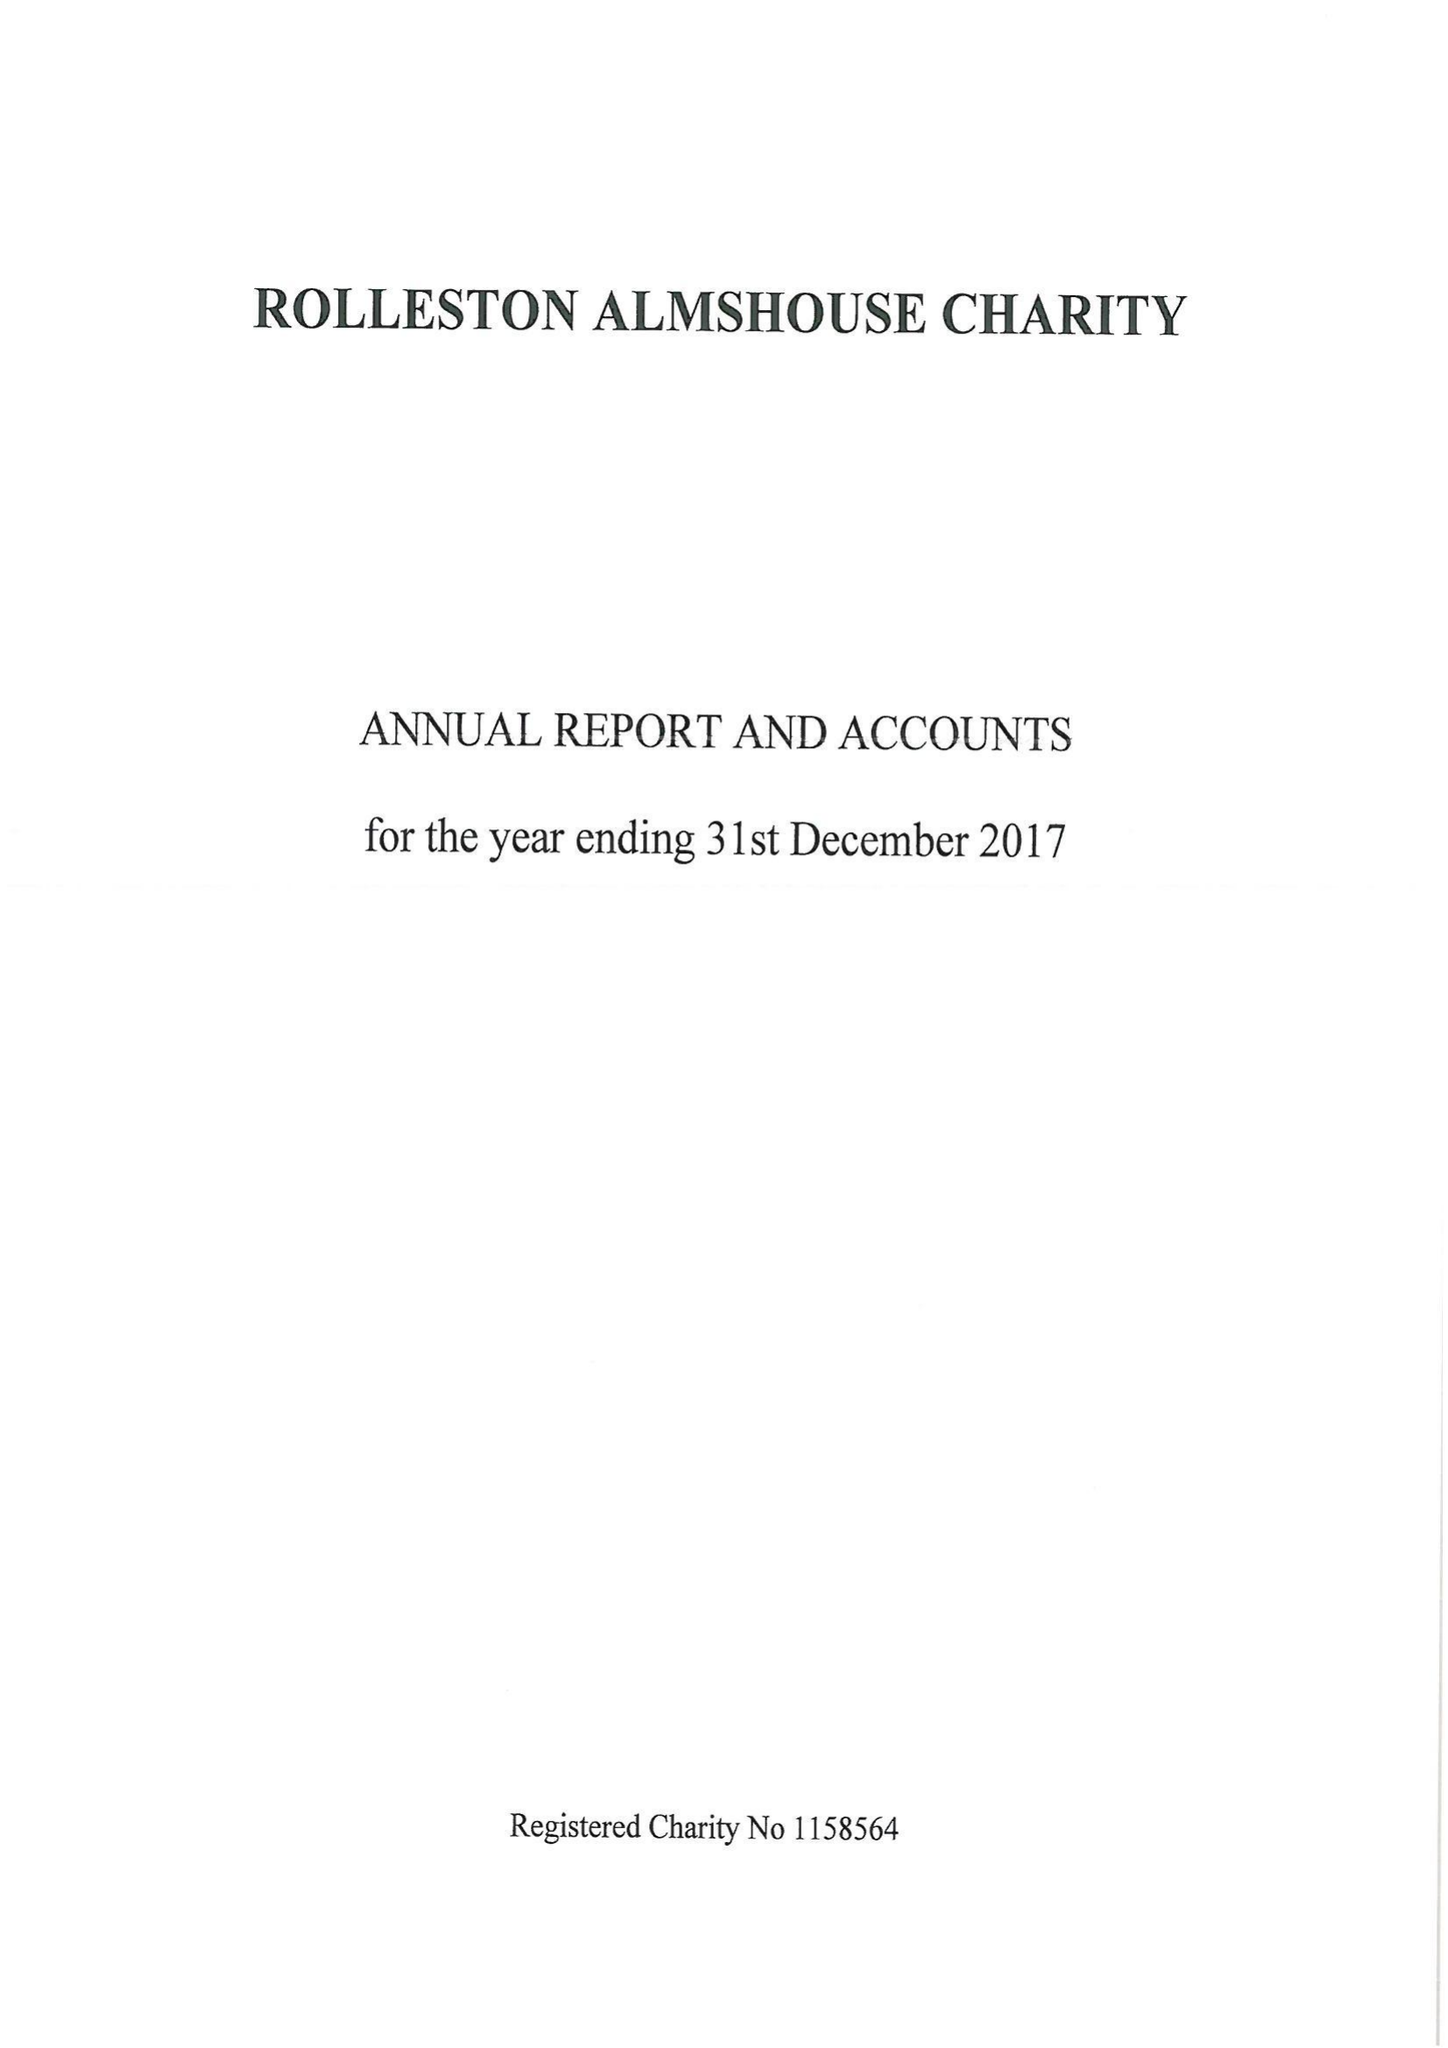What is the value for the spending_annually_in_british_pounds?
Answer the question using a single word or phrase. 21013.00 